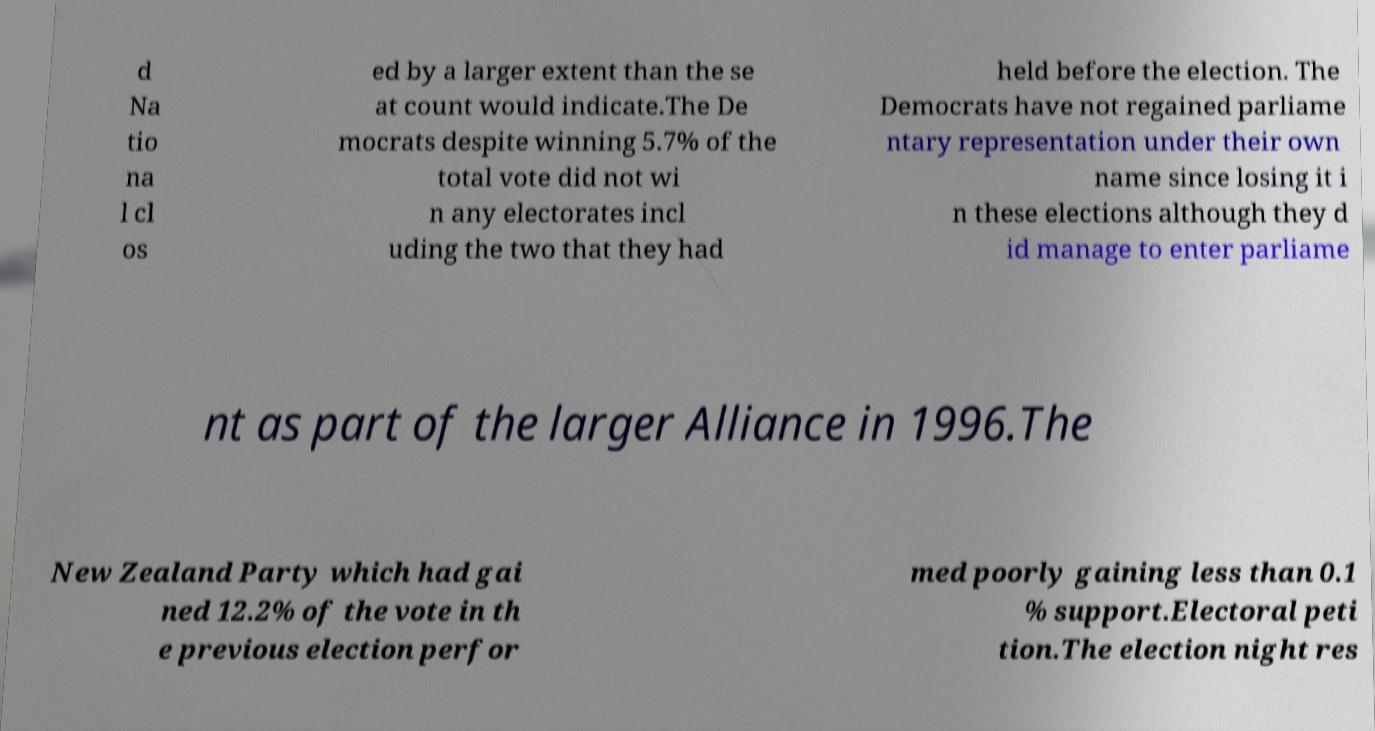Please identify and transcribe the text found in this image. d Na tio na l cl os ed by a larger extent than the se at count would indicate.The De mocrats despite winning 5.7% of the total vote did not wi n any electorates incl uding the two that they had held before the election. The Democrats have not regained parliame ntary representation under their own name since losing it i n these elections although they d id manage to enter parliame nt as part of the larger Alliance in 1996.The New Zealand Party which had gai ned 12.2% of the vote in th e previous election perfor med poorly gaining less than 0.1 % support.Electoral peti tion.The election night res 